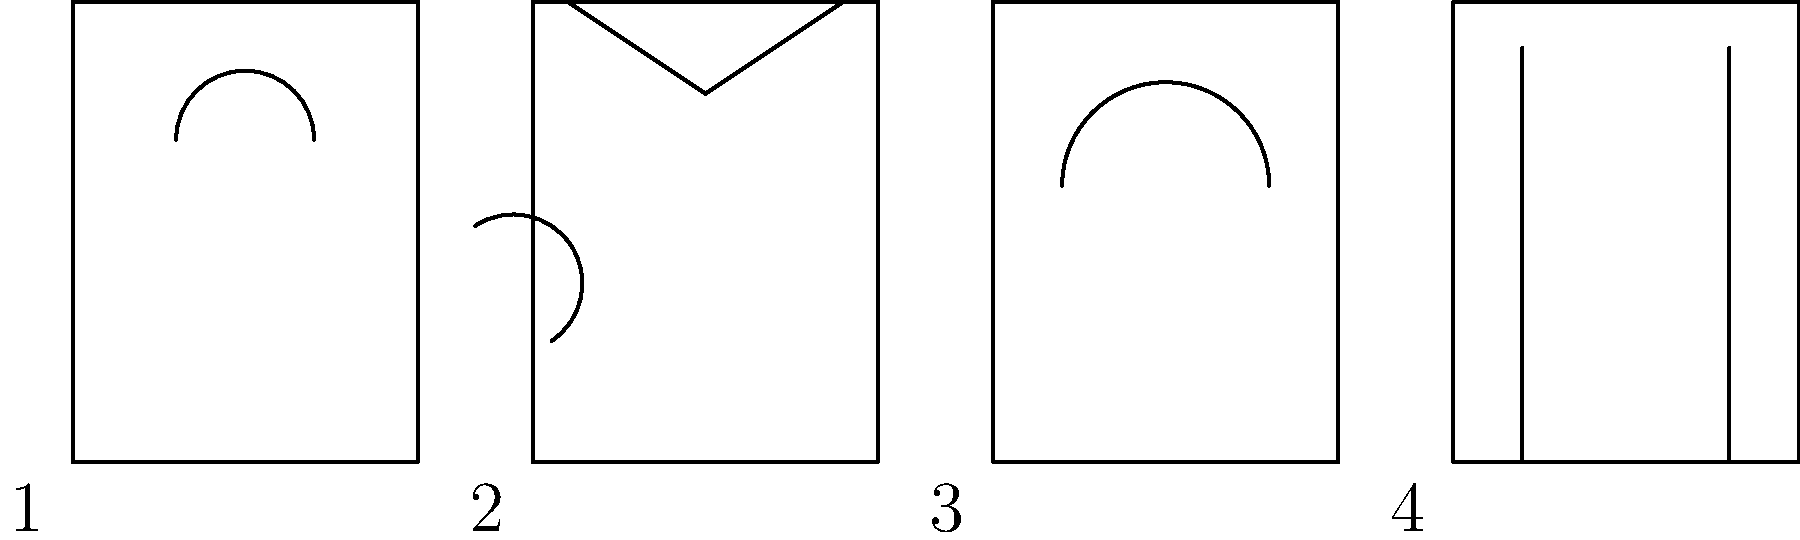Match the architectural styles depicted in the building facade sketches to their corresponding historical periods:

A. Renaissance
B. Baroque
C. Gothic
D. Neoclassical

1. _____
2. _____
3. _____
4. _____ To match the architectural styles to their historical periods, we need to analyze the key features of each facade:

1. Gothic (12th-16th century):
   - Characterized by pointed arches
   - Sketch 1 shows two pointed arches, typical of Gothic architecture

2. Renaissance (14th-17th century):
   - Features triangular pediments and symmetry
   - Sketch 2 displays a triangular roof-like structure, indicative of Renaissance style

3. Baroque (17th-18th century):
   - Known for curved lines and ornate designs
   - Sketch 3 shows a curved arch, representing Baroque's emphasis on curves

4. Neoclassical (18th-19th century):
   - Inspired by classical Greek and Roman architecture
   - Sketch 4 depicts simple, straight columns, a hallmark of Neoclassical design

By matching these characteristics to the sketches, we can determine the correct order:

1. Gothic
2. Renaissance
3. Baroque
4. Neoclassical

This chronological order also aligns with the historical development of these architectural styles.
Answer: 1. C, 2. A, 3. B, 4. D 